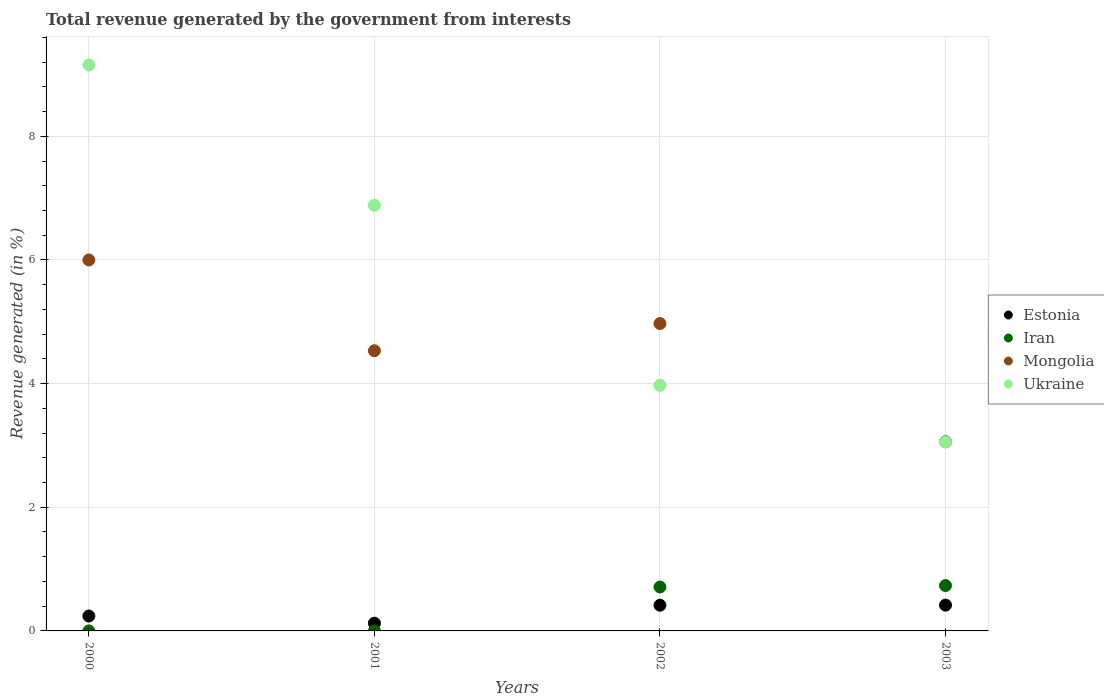Is the number of dotlines equal to the number of legend labels?
Ensure brevity in your answer.  Yes. What is the total revenue generated in Iran in 2003?
Provide a succinct answer. 0.73. Across all years, what is the maximum total revenue generated in Iran?
Ensure brevity in your answer.  0.73. Across all years, what is the minimum total revenue generated in Mongolia?
Keep it short and to the point. 3.06. In which year was the total revenue generated in Estonia maximum?
Ensure brevity in your answer.  2003. In which year was the total revenue generated in Iran minimum?
Give a very brief answer. 2000. What is the total total revenue generated in Ukraine in the graph?
Ensure brevity in your answer.  23.07. What is the difference between the total revenue generated in Estonia in 2000 and that in 2002?
Make the answer very short. -0.17. What is the difference between the total revenue generated in Iran in 2002 and the total revenue generated in Estonia in 2000?
Your answer should be compact. 0.47. What is the average total revenue generated in Mongolia per year?
Make the answer very short. 4.64. In the year 2001, what is the difference between the total revenue generated in Iran and total revenue generated in Ukraine?
Make the answer very short. -6.88. What is the ratio of the total revenue generated in Mongolia in 2000 to that in 2001?
Keep it short and to the point. 1.32. Is the total revenue generated in Mongolia in 2000 less than that in 2002?
Ensure brevity in your answer.  No. Is the difference between the total revenue generated in Iran in 2000 and 2001 greater than the difference between the total revenue generated in Ukraine in 2000 and 2001?
Give a very brief answer. No. What is the difference between the highest and the second highest total revenue generated in Iran?
Provide a short and direct response. 0.02. What is the difference between the highest and the lowest total revenue generated in Estonia?
Ensure brevity in your answer.  0.29. In how many years, is the total revenue generated in Estonia greater than the average total revenue generated in Estonia taken over all years?
Make the answer very short. 2. Is the sum of the total revenue generated in Iran in 2002 and 2003 greater than the maximum total revenue generated in Estonia across all years?
Give a very brief answer. Yes. Is it the case that in every year, the sum of the total revenue generated in Mongolia and total revenue generated in Ukraine  is greater than the sum of total revenue generated in Iran and total revenue generated in Estonia?
Ensure brevity in your answer.  No. Does the total revenue generated in Estonia monotonically increase over the years?
Your response must be concise. No. Is the total revenue generated in Iran strictly less than the total revenue generated in Estonia over the years?
Give a very brief answer. No. How many dotlines are there?
Provide a succinct answer. 4. What is the difference between two consecutive major ticks on the Y-axis?
Make the answer very short. 2. Where does the legend appear in the graph?
Offer a very short reply. Center right. How many legend labels are there?
Give a very brief answer. 4. How are the legend labels stacked?
Your answer should be very brief. Vertical. What is the title of the graph?
Keep it short and to the point. Total revenue generated by the government from interests. Does "Bulgaria" appear as one of the legend labels in the graph?
Ensure brevity in your answer.  No. What is the label or title of the Y-axis?
Offer a very short reply. Revenue generated (in %). What is the Revenue generated (in %) in Estonia in 2000?
Give a very brief answer. 0.24. What is the Revenue generated (in %) in Iran in 2000?
Your answer should be very brief. 5.52099100195348e-5. What is the Revenue generated (in %) in Mongolia in 2000?
Provide a succinct answer. 6. What is the Revenue generated (in %) in Ukraine in 2000?
Provide a succinct answer. 9.15. What is the Revenue generated (in %) of Estonia in 2001?
Your answer should be very brief. 0.12. What is the Revenue generated (in %) of Iran in 2001?
Offer a very short reply. 7.09598447964424e-5. What is the Revenue generated (in %) of Mongolia in 2001?
Keep it short and to the point. 4.53. What is the Revenue generated (in %) of Ukraine in 2001?
Keep it short and to the point. 6.88. What is the Revenue generated (in %) of Estonia in 2002?
Provide a succinct answer. 0.42. What is the Revenue generated (in %) in Iran in 2002?
Make the answer very short. 0.71. What is the Revenue generated (in %) in Mongolia in 2002?
Your response must be concise. 4.97. What is the Revenue generated (in %) of Ukraine in 2002?
Make the answer very short. 3.97. What is the Revenue generated (in %) in Estonia in 2003?
Your answer should be compact. 0.42. What is the Revenue generated (in %) in Iran in 2003?
Give a very brief answer. 0.73. What is the Revenue generated (in %) of Mongolia in 2003?
Ensure brevity in your answer.  3.06. What is the Revenue generated (in %) of Ukraine in 2003?
Give a very brief answer. 3.05. Across all years, what is the maximum Revenue generated (in %) in Estonia?
Your response must be concise. 0.42. Across all years, what is the maximum Revenue generated (in %) of Iran?
Your answer should be very brief. 0.73. Across all years, what is the maximum Revenue generated (in %) in Mongolia?
Your answer should be very brief. 6. Across all years, what is the maximum Revenue generated (in %) in Ukraine?
Keep it short and to the point. 9.15. Across all years, what is the minimum Revenue generated (in %) in Estonia?
Provide a succinct answer. 0.12. Across all years, what is the minimum Revenue generated (in %) of Iran?
Provide a succinct answer. 5.52099100195348e-5. Across all years, what is the minimum Revenue generated (in %) of Mongolia?
Keep it short and to the point. 3.06. Across all years, what is the minimum Revenue generated (in %) of Ukraine?
Offer a very short reply. 3.05. What is the total Revenue generated (in %) in Estonia in the graph?
Give a very brief answer. 1.2. What is the total Revenue generated (in %) in Iran in the graph?
Give a very brief answer. 1.44. What is the total Revenue generated (in %) of Mongolia in the graph?
Your answer should be compact. 18.56. What is the total Revenue generated (in %) of Ukraine in the graph?
Give a very brief answer. 23.07. What is the difference between the Revenue generated (in %) of Estonia in 2000 and that in 2001?
Offer a very short reply. 0.12. What is the difference between the Revenue generated (in %) in Iran in 2000 and that in 2001?
Ensure brevity in your answer.  -0. What is the difference between the Revenue generated (in %) of Mongolia in 2000 and that in 2001?
Offer a terse response. 1.47. What is the difference between the Revenue generated (in %) in Ukraine in 2000 and that in 2001?
Offer a terse response. 2.27. What is the difference between the Revenue generated (in %) in Estonia in 2000 and that in 2002?
Give a very brief answer. -0.17. What is the difference between the Revenue generated (in %) in Iran in 2000 and that in 2002?
Offer a very short reply. -0.71. What is the difference between the Revenue generated (in %) in Mongolia in 2000 and that in 2002?
Provide a short and direct response. 1.03. What is the difference between the Revenue generated (in %) of Ukraine in 2000 and that in 2002?
Ensure brevity in your answer.  5.18. What is the difference between the Revenue generated (in %) of Estonia in 2000 and that in 2003?
Your response must be concise. -0.18. What is the difference between the Revenue generated (in %) of Iran in 2000 and that in 2003?
Offer a very short reply. -0.73. What is the difference between the Revenue generated (in %) of Mongolia in 2000 and that in 2003?
Your response must be concise. 2.94. What is the difference between the Revenue generated (in %) in Ukraine in 2000 and that in 2003?
Make the answer very short. 6.1. What is the difference between the Revenue generated (in %) of Estonia in 2001 and that in 2002?
Your answer should be very brief. -0.29. What is the difference between the Revenue generated (in %) in Iran in 2001 and that in 2002?
Keep it short and to the point. -0.71. What is the difference between the Revenue generated (in %) of Mongolia in 2001 and that in 2002?
Offer a very short reply. -0.44. What is the difference between the Revenue generated (in %) in Ukraine in 2001 and that in 2002?
Provide a succinct answer. 2.91. What is the difference between the Revenue generated (in %) in Estonia in 2001 and that in 2003?
Your answer should be very brief. -0.29. What is the difference between the Revenue generated (in %) in Iran in 2001 and that in 2003?
Offer a terse response. -0.73. What is the difference between the Revenue generated (in %) in Mongolia in 2001 and that in 2003?
Provide a succinct answer. 1.47. What is the difference between the Revenue generated (in %) of Ukraine in 2001 and that in 2003?
Your answer should be very brief. 3.83. What is the difference between the Revenue generated (in %) of Estonia in 2002 and that in 2003?
Ensure brevity in your answer.  -0. What is the difference between the Revenue generated (in %) in Iran in 2002 and that in 2003?
Make the answer very short. -0.02. What is the difference between the Revenue generated (in %) in Mongolia in 2002 and that in 2003?
Make the answer very short. 1.91. What is the difference between the Revenue generated (in %) of Ukraine in 2002 and that in 2003?
Give a very brief answer. 0.92. What is the difference between the Revenue generated (in %) of Estonia in 2000 and the Revenue generated (in %) of Iran in 2001?
Keep it short and to the point. 0.24. What is the difference between the Revenue generated (in %) of Estonia in 2000 and the Revenue generated (in %) of Mongolia in 2001?
Your answer should be very brief. -4.29. What is the difference between the Revenue generated (in %) of Estonia in 2000 and the Revenue generated (in %) of Ukraine in 2001?
Ensure brevity in your answer.  -6.64. What is the difference between the Revenue generated (in %) of Iran in 2000 and the Revenue generated (in %) of Mongolia in 2001?
Your answer should be very brief. -4.53. What is the difference between the Revenue generated (in %) of Iran in 2000 and the Revenue generated (in %) of Ukraine in 2001?
Ensure brevity in your answer.  -6.88. What is the difference between the Revenue generated (in %) in Mongolia in 2000 and the Revenue generated (in %) in Ukraine in 2001?
Provide a short and direct response. -0.89. What is the difference between the Revenue generated (in %) in Estonia in 2000 and the Revenue generated (in %) in Iran in 2002?
Your answer should be very brief. -0.47. What is the difference between the Revenue generated (in %) in Estonia in 2000 and the Revenue generated (in %) in Mongolia in 2002?
Give a very brief answer. -4.73. What is the difference between the Revenue generated (in %) of Estonia in 2000 and the Revenue generated (in %) of Ukraine in 2002?
Make the answer very short. -3.73. What is the difference between the Revenue generated (in %) in Iran in 2000 and the Revenue generated (in %) in Mongolia in 2002?
Make the answer very short. -4.97. What is the difference between the Revenue generated (in %) in Iran in 2000 and the Revenue generated (in %) in Ukraine in 2002?
Your answer should be very brief. -3.97. What is the difference between the Revenue generated (in %) in Mongolia in 2000 and the Revenue generated (in %) in Ukraine in 2002?
Your answer should be very brief. 2.03. What is the difference between the Revenue generated (in %) of Estonia in 2000 and the Revenue generated (in %) of Iran in 2003?
Offer a very short reply. -0.49. What is the difference between the Revenue generated (in %) in Estonia in 2000 and the Revenue generated (in %) in Mongolia in 2003?
Provide a short and direct response. -2.82. What is the difference between the Revenue generated (in %) in Estonia in 2000 and the Revenue generated (in %) in Ukraine in 2003?
Ensure brevity in your answer.  -2.81. What is the difference between the Revenue generated (in %) of Iran in 2000 and the Revenue generated (in %) of Mongolia in 2003?
Make the answer very short. -3.06. What is the difference between the Revenue generated (in %) in Iran in 2000 and the Revenue generated (in %) in Ukraine in 2003?
Your answer should be compact. -3.05. What is the difference between the Revenue generated (in %) of Mongolia in 2000 and the Revenue generated (in %) of Ukraine in 2003?
Your answer should be very brief. 2.94. What is the difference between the Revenue generated (in %) in Estonia in 2001 and the Revenue generated (in %) in Iran in 2002?
Offer a very short reply. -0.59. What is the difference between the Revenue generated (in %) in Estonia in 2001 and the Revenue generated (in %) in Mongolia in 2002?
Keep it short and to the point. -4.85. What is the difference between the Revenue generated (in %) in Estonia in 2001 and the Revenue generated (in %) in Ukraine in 2002?
Ensure brevity in your answer.  -3.85. What is the difference between the Revenue generated (in %) in Iran in 2001 and the Revenue generated (in %) in Mongolia in 2002?
Your answer should be compact. -4.97. What is the difference between the Revenue generated (in %) of Iran in 2001 and the Revenue generated (in %) of Ukraine in 2002?
Provide a short and direct response. -3.97. What is the difference between the Revenue generated (in %) of Mongolia in 2001 and the Revenue generated (in %) of Ukraine in 2002?
Your answer should be very brief. 0.56. What is the difference between the Revenue generated (in %) of Estonia in 2001 and the Revenue generated (in %) of Iran in 2003?
Offer a terse response. -0.61. What is the difference between the Revenue generated (in %) in Estonia in 2001 and the Revenue generated (in %) in Mongolia in 2003?
Your answer should be very brief. -2.94. What is the difference between the Revenue generated (in %) in Estonia in 2001 and the Revenue generated (in %) in Ukraine in 2003?
Provide a short and direct response. -2.93. What is the difference between the Revenue generated (in %) in Iran in 2001 and the Revenue generated (in %) in Mongolia in 2003?
Provide a succinct answer. -3.06. What is the difference between the Revenue generated (in %) in Iran in 2001 and the Revenue generated (in %) in Ukraine in 2003?
Keep it short and to the point. -3.05. What is the difference between the Revenue generated (in %) in Mongolia in 2001 and the Revenue generated (in %) in Ukraine in 2003?
Keep it short and to the point. 1.48. What is the difference between the Revenue generated (in %) in Estonia in 2002 and the Revenue generated (in %) in Iran in 2003?
Your answer should be very brief. -0.32. What is the difference between the Revenue generated (in %) in Estonia in 2002 and the Revenue generated (in %) in Mongolia in 2003?
Provide a short and direct response. -2.64. What is the difference between the Revenue generated (in %) of Estonia in 2002 and the Revenue generated (in %) of Ukraine in 2003?
Your answer should be very brief. -2.64. What is the difference between the Revenue generated (in %) of Iran in 2002 and the Revenue generated (in %) of Mongolia in 2003?
Make the answer very short. -2.35. What is the difference between the Revenue generated (in %) of Iran in 2002 and the Revenue generated (in %) of Ukraine in 2003?
Keep it short and to the point. -2.34. What is the difference between the Revenue generated (in %) in Mongolia in 2002 and the Revenue generated (in %) in Ukraine in 2003?
Keep it short and to the point. 1.92. What is the average Revenue generated (in %) in Estonia per year?
Provide a short and direct response. 0.3. What is the average Revenue generated (in %) of Iran per year?
Provide a short and direct response. 0.36. What is the average Revenue generated (in %) of Mongolia per year?
Offer a terse response. 4.64. What is the average Revenue generated (in %) of Ukraine per year?
Provide a short and direct response. 5.77. In the year 2000, what is the difference between the Revenue generated (in %) in Estonia and Revenue generated (in %) in Iran?
Provide a succinct answer. 0.24. In the year 2000, what is the difference between the Revenue generated (in %) of Estonia and Revenue generated (in %) of Mongolia?
Give a very brief answer. -5.76. In the year 2000, what is the difference between the Revenue generated (in %) of Estonia and Revenue generated (in %) of Ukraine?
Provide a short and direct response. -8.91. In the year 2000, what is the difference between the Revenue generated (in %) of Iran and Revenue generated (in %) of Mongolia?
Provide a short and direct response. -6. In the year 2000, what is the difference between the Revenue generated (in %) of Iran and Revenue generated (in %) of Ukraine?
Ensure brevity in your answer.  -9.15. In the year 2000, what is the difference between the Revenue generated (in %) in Mongolia and Revenue generated (in %) in Ukraine?
Offer a very short reply. -3.16. In the year 2001, what is the difference between the Revenue generated (in %) in Estonia and Revenue generated (in %) in Iran?
Make the answer very short. 0.12. In the year 2001, what is the difference between the Revenue generated (in %) of Estonia and Revenue generated (in %) of Mongolia?
Provide a short and direct response. -4.41. In the year 2001, what is the difference between the Revenue generated (in %) of Estonia and Revenue generated (in %) of Ukraine?
Your answer should be compact. -6.76. In the year 2001, what is the difference between the Revenue generated (in %) of Iran and Revenue generated (in %) of Mongolia?
Your answer should be compact. -4.53. In the year 2001, what is the difference between the Revenue generated (in %) in Iran and Revenue generated (in %) in Ukraine?
Give a very brief answer. -6.88. In the year 2001, what is the difference between the Revenue generated (in %) in Mongolia and Revenue generated (in %) in Ukraine?
Ensure brevity in your answer.  -2.35. In the year 2002, what is the difference between the Revenue generated (in %) in Estonia and Revenue generated (in %) in Iran?
Give a very brief answer. -0.29. In the year 2002, what is the difference between the Revenue generated (in %) of Estonia and Revenue generated (in %) of Mongolia?
Provide a succinct answer. -4.56. In the year 2002, what is the difference between the Revenue generated (in %) of Estonia and Revenue generated (in %) of Ukraine?
Your answer should be very brief. -3.56. In the year 2002, what is the difference between the Revenue generated (in %) of Iran and Revenue generated (in %) of Mongolia?
Provide a succinct answer. -4.26. In the year 2002, what is the difference between the Revenue generated (in %) in Iran and Revenue generated (in %) in Ukraine?
Give a very brief answer. -3.26. In the year 2002, what is the difference between the Revenue generated (in %) of Mongolia and Revenue generated (in %) of Ukraine?
Give a very brief answer. 1. In the year 2003, what is the difference between the Revenue generated (in %) in Estonia and Revenue generated (in %) in Iran?
Provide a succinct answer. -0.32. In the year 2003, what is the difference between the Revenue generated (in %) in Estonia and Revenue generated (in %) in Mongolia?
Your answer should be compact. -2.64. In the year 2003, what is the difference between the Revenue generated (in %) of Estonia and Revenue generated (in %) of Ukraine?
Offer a very short reply. -2.64. In the year 2003, what is the difference between the Revenue generated (in %) of Iran and Revenue generated (in %) of Mongolia?
Your answer should be very brief. -2.33. In the year 2003, what is the difference between the Revenue generated (in %) of Iran and Revenue generated (in %) of Ukraine?
Offer a terse response. -2.32. In the year 2003, what is the difference between the Revenue generated (in %) of Mongolia and Revenue generated (in %) of Ukraine?
Make the answer very short. 0.01. What is the ratio of the Revenue generated (in %) of Estonia in 2000 to that in 2001?
Offer a very short reply. 1.93. What is the ratio of the Revenue generated (in %) in Iran in 2000 to that in 2001?
Make the answer very short. 0.78. What is the ratio of the Revenue generated (in %) of Mongolia in 2000 to that in 2001?
Your answer should be very brief. 1.32. What is the ratio of the Revenue generated (in %) of Ukraine in 2000 to that in 2001?
Give a very brief answer. 1.33. What is the ratio of the Revenue generated (in %) in Estonia in 2000 to that in 2002?
Your response must be concise. 0.58. What is the ratio of the Revenue generated (in %) of Iran in 2000 to that in 2002?
Provide a succinct answer. 0. What is the ratio of the Revenue generated (in %) in Mongolia in 2000 to that in 2002?
Keep it short and to the point. 1.21. What is the ratio of the Revenue generated (in %) of Ukraine in 2000 to that in 2002?
Offer a terse response. 2.31. What is the ratio of the Revenue generated (in %) in Estonia in 2000 to that in 2003?
Offer a very short reply. 0.58. What is the ratio of the Revenue generated (in %) in Iran in 2000 to that in 2003?
Make the answer very short. 0. What is the ratio of the Revenue generated (in %) of Mongolia in 2000 to that in 2003?
Keep it short and to the point. 1.96. What is the ratio of the Revenue generated (in %) in Ukraine in 2000 to that in 2003?
Your answer should be compact. 3. What is the ratio of the Revenue generated (in %) in Estonia in 2001 to that in 2002?
Offer a terse response. 0.3. What is the ratio of the Revenue generated (in %) of Iran in 2001 to that in 2002?
Offer a very short reply. 0. What is the ratio of the Revenue generated (in %) in Mongolia in 2001 to that in 2002?
Your answer should be compact. 0.91. What is the ratio of the Revenue generated (in %) in Ukraine in 2001 to that in 2002?
Provide a short and direct response. 1.73. What is the ratio of the Revenue generated (in %) of Estonia in 2001 to that in 2003?
Provide a succinct answer. 0.3. What is the ratio of the Revenue generated (in %) of Mongolia in 2001 to that in 2003?
Offer a very short reply. 1.48. What is the ratio of the Revenue generated (in %) in Ukraine in 2001 to that in 2003?
Keep it short and to the point. 2.25. What is the ratio of the Revenue generated (in %) of Estonia in 2002 to that in 2003?
Your response must be concise. 1. What is the ratio of the Revenue generated (in %) of Iran in 2002 to that in 2003?
Your response must be concise. 0.97. What is the ratio of the Revenue generated (in %) in Mongolia in 2002 to that in 2003?
Provide a succinct answer. 1.62. What is the ratio of the Revenue generated (in %) of Ukraine in 2002 to that in 2003?
Keep it short and to the point. 1.3. What is the difference between the highest and the second highest Revenue generated (in %) in Estonia?
Offer a very short reply. 0. What is the difference between the highest and the second highest Revenue generated (in %) in Iran?
Keep it short and to the point. 0.02. What is the difference between the highest and the second highest Revenue generated (in %) of Mongolia?
Provide a succinct answer. 1.03. What is the difference between the highest and the second highest Revenue generated (in %) in Ukraine?
Provide a short and direct response. 2.27. What is the difference between the highest and the lowest Revenue generated (in %) in Estonia?
Make the answer very short. 0.29. What is the difference between the highest and the lowest Revenue generated (in %) in Iran?
Your answer should be compact. 0.73. What is the difference between the highest and the lowest Revenue generated (in %) in Mongolia?
Your answer should be compact. 2.94. What is the difference between the highest and the lowest Revenue generated (in %) of Ukraine?
Give a very brief answer. 6.1. 